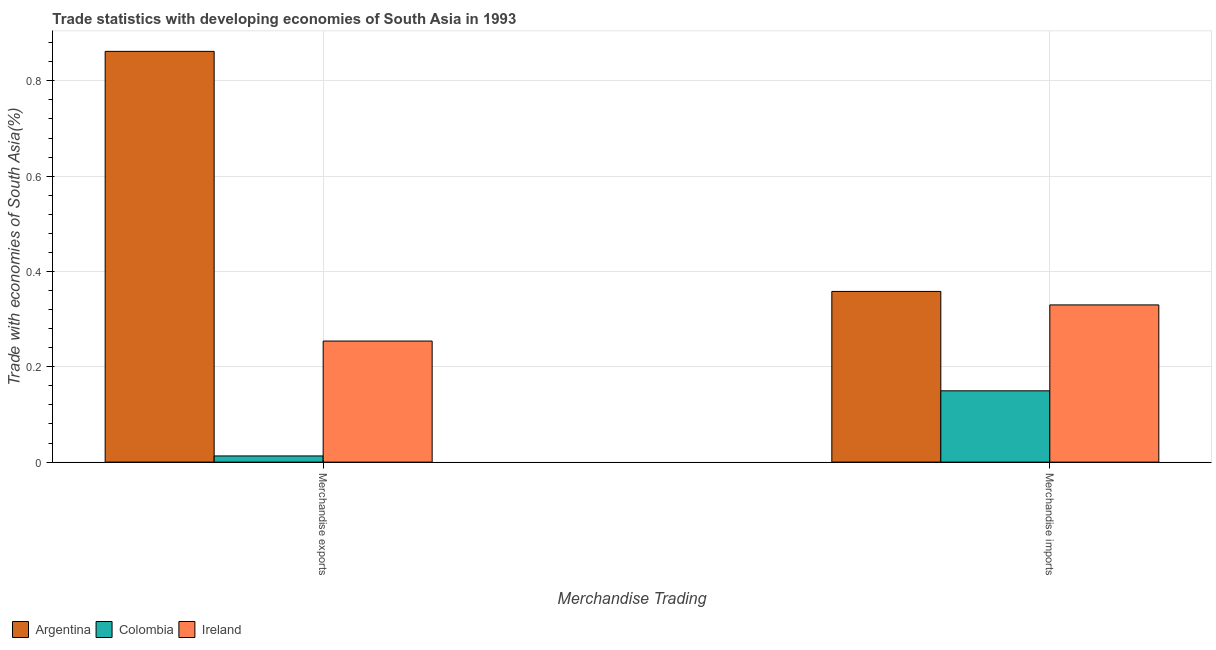How many different coloured bars are there?
Offer a very short reply. 3. Are the number of bars on each tick of the X-axis equal?
Your answer should be compact. Yes. What is the merchandise imports in Argentina?
Provide a succinct answer. 0.36. Across all countries, what is the maximum merchandise exports?
Ensure brevity in your answer.  0.86. Across all countries, what is the minimum merchandise imports?
Make the answer very short. 0.15. In which country was the merchandise imports maximum?
Give a very brief answer. Argentina. In which country was the merchandise imports minimum?
Ensure brevity in your answer.  Colombia. What is the total merchandise exports in the graph?
Your response must be concise. 1.13. What is the difference between the merchandise imports in Colombia and that in Ireland?
Your answer should be compact. -0.18. What is the difference between the merchandise exports in Colombia and the merchandise imports in Argentina?
Give a very brief answer. -0.35. What is the average merchandise imports per country?
Make the answer very short. 0.28. What is the difference between the merchandise imports and merchandise exports in Ireland?
Your answer should be very brief. 0.08. In how many countries, is the merchandise imports greater than 0.44 %?
Your answer should be very brief. 0. What is the ratio of the merchandise imports in Ireland to that in Argentina?
Give a very brief answer. 0.92. In how many countries, is the merchandise exports greater than the average merchandise exports taken over all countries?
Make the answer very short. 1. What does the 3rd bar from the left in Merchandise imports represents?
Ensure brevity in your answer.  Ireland. How many bars are there?
Your answer should be compact. 6. Are all the bars in the graph horizontal?
Your response must be concise. No. How many countries are there in the graph?
Offer a very short reply. 3. Are the values on the major ticks of Y-axis written in scientific E-notation?
Provide a short and direct response. No. Where does the legend appear in the graph?
Your answer should be very brief. Bottom left. How many legend labels are there?
Give a very brief answer. 3. How are the legend labels stacked?
Offer a terse response. Horizontal. What is the title of the graph?
Give a very brief answer. Trade statistics with developing economies of South Asia in 1993. What is the label or title of the X-axis?
Give a very brief answer. Merchandise Trading. What is the label or title of the Y-axis?
Your answer should be compact. Trade with economies of South Asia(%). What is the Trade with economies of South Asia(%) of Argentina in Merchandise exports?
Provide a short and direct response. 0.86. What is the Trade with economies of South Asia(%) in Colombia in Merchandise exports?
Make the answer very short. 0.01. What is the Trade with economies of South Asia(%) of Ireland in Merchandise exports?
Ensure brevity in your answer.  0.25. What is the Trade with economies of South Asia(%) of Argentina in Merchandise imports?
Provide a succinct answer. 0.36. What is the Trade with economies of South Asia(%) in Colombia in Merchandise imports?
Make the answer very short. 0.15. What is the Trade with economies of South Asia(%) in Ireland in Merchandise imports?
Ensure brevity in your answer.  0.33. Across all Merchandise Trading, what is the maximum Trade with economies of South Asia(%) of Argentina?
Keep it short and to the point. 0.86. Across all Merchandise Trading, what is the maximum Trade with economies of South Asia(%) of Colombia?
Ensure brevity in your answer.  0.15. Across all Merchandise Trading, what is the maximum Trade with economies of South Asia(%) of Ireland?
Offer a terse response. 0.33. Across all Merchandise Trading, what is the minimum Trade with economies of South Asia(%) in Argentina?
Make the answer very short. 0.36. Across all Merchandise Trading, what is the minimum Trade with economies of South Asia(%) of Colombia?
Provide a succinct answer. 0.01. Across all Merchandise Trading, what is the minimum Trade with economies of South Asia(%) of Ireland?
Keep it short and to the point. 0.25. What is the total Trade with economies of South Asia(%) of Argentina in the graph?
Offer a very short reply. 1.22. What is the total Trade with economies of South Asia(%) of Colombia in the graph?
Offer a very short reply. 0.16. What is the total Trade with economies of South Asia(%) in Ireland in the graph?
Give a very brief answer. 0.58. What is the difference between the Trade with economies of South Asia(%) of Argentina in Merchandise exports and that in Merchandise imports?
Offer a very short reply. 0.5. What is the difference between the Trade with economies of South Asia(%) of Colombia in Merchandise exports and that in Merchandise imports?
Your response must be concise. -0.14. What is the difference between the Trade with economies of South Asia(%) in Ireland in Merchandise exports and that in Merchandise imports?
Your answer should be very brief. -0.08. What is the difference between the Trade with economies of South Asia(%) in Argentina in Merchandise exports and the Trade with economies of South Asia(%) in Colombia in Merchandise imports?
Make the answer very short. 0.71. What is the difference between the Trade with economies of South Asia(%) of Argentina in Merchandise exports and the Trade with economies of South Asia(%) of Ireland in Merchandise imports?
Provide a succinct answer. 0.53. What is the difference between the Trade with economies of South Asia(%) of Colombia in Merchandise exports and the Trade with economies of South Asia(%) of Ireland in Merchandise imports?
Ensure brevity in your answer.  -0.32. What is the average Trade with economies of South Asia(%) of Argentina per Merchandise Trading?
Offer a terse response. 0.61. What is the average Trade with economies of South Asia(%) in Colombia per Merchandise Trading?
Provide a short and direct response. 0.08. What is the average Trade with economies of South Asia(%) in Ireland per Merchandise Trading?
Give a very brief answer. 0.29. What is the difference between the Trade with economies of South Asia(%) of Argentina and Trade with economies of South Asia(%) of Colombia in Merchandise exports?
Make the answer very short. 0.85. What is the difference between the Trade with economies of South Asia(%) of Argentina and Trade with economies of South Asia(%) of Ireland in Merchandise exports?
Offer a terse response. 0.61. What is the difference between the Trade with economies of South Asia(%) in Colombia and Trade with economies of South Asia(%) in Ireland in Merchandise exports?
Keep it short and to the point. -0.24. What is the difference between the Trade with economies of South Asia(%) of Argentina and Trade with economies of South Asia(%) of Colombia in Merchandise imports?
Provide a short and direct response. 0.21. What is the difference between the Trade with economies of South Asia(%) of Argentina and Trade with economies of South Asia(%) of Ireland in Merchandise imports?
Your answer should be very brief. 0.03. What is the difference between the Trade with economies of South Asia(%) in Colombia and Trade with economies of South Asia(%) in Ireland in Merchandise imports?
Your answer should be compact. -0.18. What is the ratio of the Trade with economies of South Asia(%) in Argentina in Merchandise exports to that in Merchandise imports?
Your answer should be very brief. 2.41. What is the ratio of the Trade with economies of South Asia(%) of Colombia in Merchandise exports to that in Merchandise imports?
Your answer should be compact. 0.09. What is the ratio of the Trade with economies of South Asia(%) of Ireland in Merchandise exports to that in Merchandise imports?
Provide a short and direct response. 0.77. What is the difference between the highest and the second highest Trade with economies of South Asia(%) in Argentina?
Your response must be concise. 0.5. What is the difference between the highest and the second highest Trade with economies of South Asia(%) in Colombia?
Offer a very short reply. 0.14. What is the difference between the highest and the second highest Trade with economies of South Asia(%) in Ireland?
Your response must be concise. 0.08. What is the difference between the highest and the lowest Trade with economies of South Asia(%) of Argentina?
Offer a very short reply. 0.5. What is the difference between the highest and the lowest Trade with economies of South Asia(%) in Colombia?
Offer a very short reply. 0.14. What is the difference between the highest and the lowest Trade with economies of South Asia(%) of Ireland?
Ensure brevity in your answer.  0.08. 